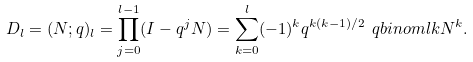<formula> <loc_0><loc_0><loc_500><loc_500>D _ { l } = ( N ; q ) _ { l } = \prod _ { j = 0 } ^ { l - 1 } ( I - q ^ { j } N ) = \sum _ { k = 0 } ^ { l } ( - 1 ) ^ { k } q ^ { k ( k - 1 ) / 2 } \ q b i n o m l k N ^ { k } .</formula> 